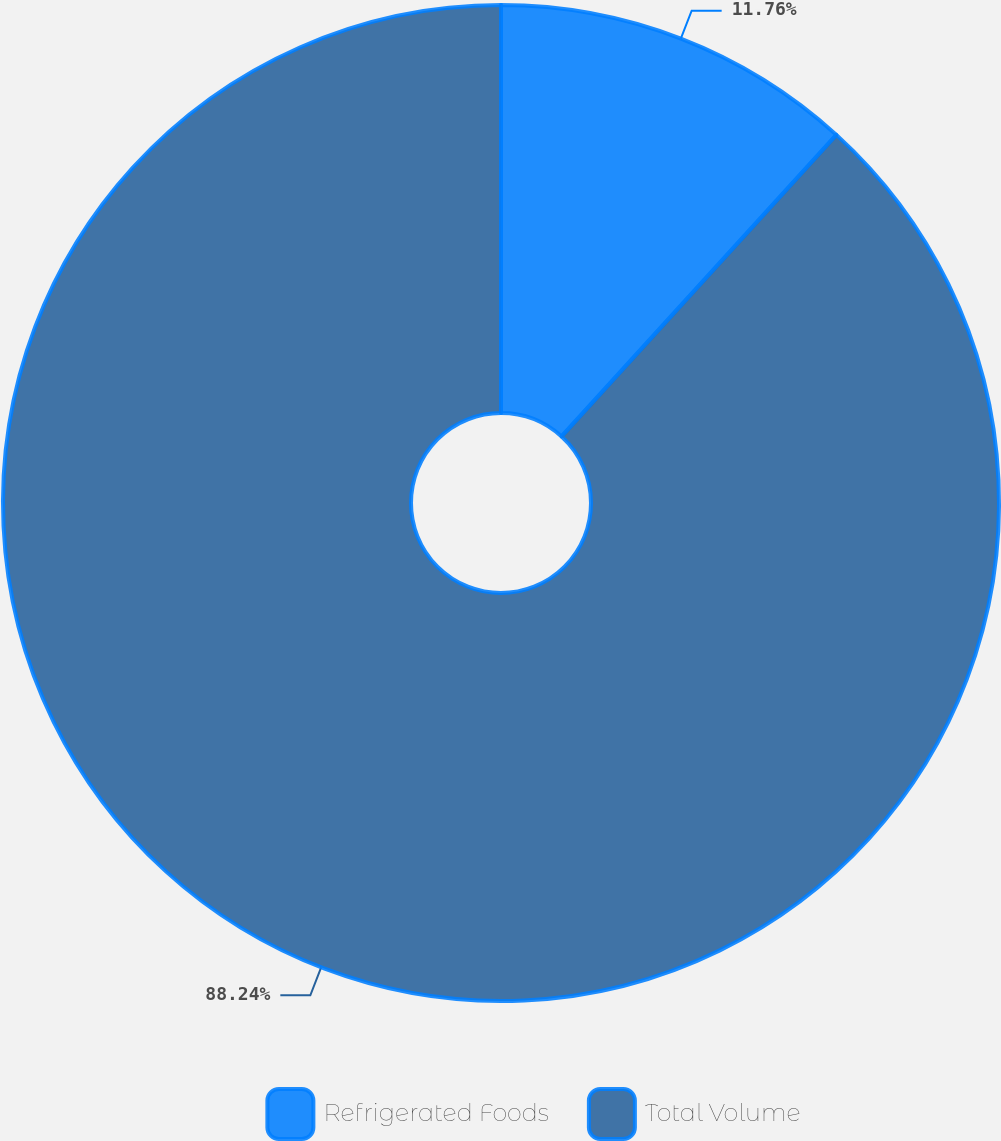Convert chart. <chart><loc_0><loc_0><loc_500><loc_500><pie_chart><fcel>Refrigerated Foods<fcel>Total Volume<nl><fcel>11.76%<fcel>88.24%<nl></chart> 